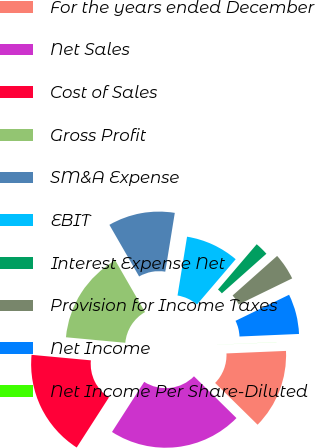Convert chart. <chart><loc_0><loc_0><loc_500><loc_500><pie_chart><fcel>For the years ended December<fcel>Net Sales<fcel>Cost of Sales<fcel>Gross Profit<fcel>SM&A Expense<fcel>EBIT<fcel>Interest Expense Net<fcel>Provision for Income Taxes<fcel>Net Income<fcel>Net Income Per Share-Diluted<nl><fcel>13.04%<fcel>21.73%<fcel>17.38%<fcel>15.21%<fcel>10.87%<fcel>8.7%<fcel>2.18%<fcel>4.35%<fcel>6.53%<fcel>0.01%<nl></chart> 